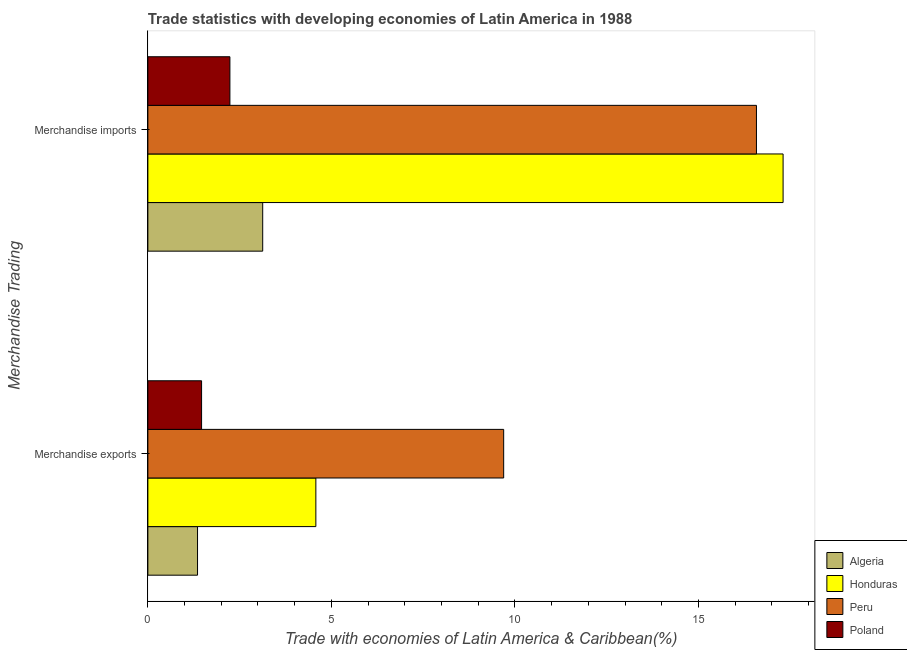How many different coloured bars are there?
Provide a short and direct response. 4. Are the number of bars per tick equal to the number of legend labels?
Ensure brevity in your answer.  Yes. How many bars are there on the 2nd tick from the bottom?
Make the answer very short. 4. What is the label of the 1st group of bars from the top?
Keep it short and to the point. Merchandise imports. What is the merchandise imports in Algeria?
Your response must be concise. 3.13. Across all countries, what is the maximum merchandise exports?
Make the answer very short. 9.69. Across all countries, what is the minimum merchandise exports?
Provide a succinct answer. 1.35. In which country was the merchandise exports minimum?
Provide a short and direct response. Algeria. What is the total merchandise exports in the graph?
Make the answer very short. 17.09. What is the difference between the merchandise exports in Poland and that in Algeria?
Your answer should be very brief. 0.11. What is the difference between the merchandise imports in Poland and the merchandise exports in Peru?
Your response must be concise. -7.46. What is the average merchandise exports per country?
Provide a succinct answer. 4.27. What is the difference between the merchandise exports and merchandise imports in Peru?
Ensure brevity in your answer.  -6.89. What is the ratio of the merchandise exports in Poland to that in Peru?
Your answer should be very brief. 0.15. What does the 2nd bar from the bottom in Merchandise exports represents?
Make the answer very short. Honduras. Are all the bars in the graph horizontal?
Offer a very short reply. Yes. How many countries are there in the graph?
Offer a very short reply. 4. What is the difference between two consecutive major ticks on the X-axis?
Provide a succinct answer. 5. Does the graph contain any zero values?
Provide a short and direct response. No. Where does the legend appear in the graph?
Provide a succinct answer. Bottom right. How many legend labels are there?
Offer a very short reply. 4. How are the legend labels stacked?
Provide a succinct answer. Vertical. What is the title of the graph?
Provide a short and direct response. Trade statistics with developing economies of Latin America in 1988. What is the label or title of the X-axis?
Make the answer very short. Trade with economies of Latin America & Caribbean(%). What is the label or title of the Y-axis?
Give a very brief answer. Merchandise Trading. What is the Trade with economies of Latin America & Caribbean(%) of Algeria in Merchandise exports?
Your response must be concise. 1.35. What is the Trade with economies of Latin America & Caribbean(%) in Honduras in Merchandise exports?
Offer a terse response. 4.58. What is the Trade with economies of Latin America & Caribbean(%) in Peru in Merchandise exports?
Your response must be concise. 9.69. What is the Trade with economies of Latin America & Caribbean(%) of Poland in Merchandise exports?
Provide a short and direct response. 1.46. What is the Trade with economies of Latin America & Caribbean(%) in Algeria in Merchandise imports?
Your answer should be very brief. 3.13. What is the Trade with economies of Latin America & Caribbean(%) of Honduras in Merchandise imports?
Give a very brief answer. 17.31. What is the Trade with economies of Latin America & Caribbean(%) of Peru in Merchandise imports?
Your answer should be very brief. 16.58. What is the Trade with economies of Latin America & Caribbean(%) of Poland in Merchandise imports?
Your answer should be very brief. 2.24. Across all Merchandise Trading, what is the maximum Trade with economies of Latin America & Caribbean(%) of Algeria?
Provide a short and direct response. 3.13. Across all Merchandise Trading, what is the maximum Trade with economies of Latin America & Caribbean(%) of Honduras?
Provide a succinct answer. 17.31. Across all Merchandise Trading, what is the maximum Trade with economies of Latin America & Caribbean(%) in Peru?
Offer a very short reply. 16.58. Across all Merchandise Trading, what is the maximum Trade with economies of Latin America & Caribbean(%) in Poland?
Give a very brief answer. 2.24. Across all Merchandise Trading, what is the minimum Trade with economies of Latin America & Caribbean(%) of Algeria?
Offer a terse response. 1.35. Across all Merchandise Trading, what is the minimum Trade with economies of Latin America & Caribbean(%) of Honduras?
Offer a terse response. 4.58. Across all Merchandise Trading, what is the minimum Trade with economies of Latin America & Caribbean(%) in Peru?
Ensure brevity in your answer.  9.69. Across all Merchandise Trading, what is the minimum Trade with economies of Latin America & Caribbean(%) of Poland?
Make the answer very short. 1.46. What is the total Trade with economies of Latin America & Caribbean(%) in Algeria in the graph?
Keep it short and to the point. 4.48. What is the total Trade with economies of Latin America & Caribbean(%) of Honduras in the graph?
Your response must be concise. 21.88. What is the total Trade with economies of Latin America & Caribbean(%) of Peru in the graph?
Keep it short and to the point. 26.27. What is the total Trade with economies of Latin America & Caribbean(%) of Poland in the graph?
Keep it short and to the point. 3.7. What is the difference between the Trade with economies of Latin America & Caribbean(%) of Algeria in Merchandise exports and that in Merchandise imports?
Make the answer very short. -1.78. What is the difference between the Trade with economies of Latin America & Caribbean(%) of Honduras in Merchandise exports and that in Merchandise imports?
Your answer should be compact. -12.73. What is the difference between the Trade with economies of Latin America & Caribbean(%) in Peru in Merchandise exports and that in Merchandise imports?
Your answer should be compact. -6.89. What is the difference between the Trade with economies of Latin America & Caribbean(%) of Poland in Merchandise exports and that in Merchandise imports?
Your response must be concise. -0.77. What is the difference between the Trade with economies of Latin America & Caribbean(%) of Algeria in Merchandise exports and the Trade with economies of Latin America & Caribbean(%) of Honduras in Merchandise imports?
Keep it short and to the point. -15.95. What is the difference between the Trade with economies of Latin America & Caribbean(%) of Algeria in Merchandise exports and the Trade with economies of Latin America & Caribbean(%) of Peru in Merchandise imports?
Your response must be concise. -15.23. What is the difference between the Trade with economies of Latin America & Caribbean(%) of Algeria in Merchandise exports and the Trade with economies of Latin America & Caribbean(%) of Poland in Merchandise imports?
Provide a short and direct response. -0.88. What is the difference between the Trade with economies of Latin America & Caribbean(%) in Honduras in Merchandise exports and the Trade with economies of Latin America & Caribbean(%) in Peru in Merchandise imports?
Offer a terse response. -12. What is the difference between the Trade with economies of Latin America & Caribbean(%) of Honduras in Merchandise exports and the Trade with economies of Latin America & Caribbean(%) of Poland in Merchandise imports?
Provide a succinct answer. 2.34. What is the difference between the Trade with economies of Latin America & Caribbean(%) in Peru in Merchandise exports and the Trade with economies of Latin America & Caribbean(%) in Poland in Merchandise imports?
Offer a very short reply. 7.46. What is the average Trade with economies of Latin America & Caribbean(%) of Algeria per Merchandise Trading?
Ensure brevity in your answer.  2.24. What is the average Trade with economies of Latin America & Caribbean(%) of Honduras per Merchandise Trading?
Provide a succinct answer. 10.94. What is the average Trade with economies of Latin America & Caribbean(%) in Peru per Merchandise Trading?
Offer a terse response. 13.14. What is the average Trade with economies of Latin America & Caribbean(%) in Poland per Merchandise Trading?
Your answer should be very brief. 1.85. What is the difference between the Trade with economies of Latin America & Caribbean(%) of Algeria and Trade with economies of Latin America & Caribbean(%) of Honduras in Merchandise exports?
Your response must be concise. -3.22. What is the difference between the Trade with economies of Latin America & Caribbean(%) in Algeria and Trade with economies of Latin America & Caribbean(%) in Peru in Merchandise exports?
Provide a short and direct response. -8.34. What is the difference between the Trade with economies of Latin America & Caribbean(%) of Algeria and Trade with economies of Latin America & Caribbean(%) of Poland in Merchandise exports?
Your response must be concise. -0.11. What is the difference between the Trade with economies of Latin America & Caribbean(%) in Honduras and Trade with economies of Latin America & Caribbean(%) in Peru in Merchandise exports?
Your answer should be very brief. -5.12. What is the difference between the Trade with economies of Latin America & Caribbean(%) of Honduras and Trade with economies of Latin America & Caribbean(%) of Poland in Merchandise exports?
Provide a short and direct response. 3.11. What is the difference between the Trade with economies of Latin America & Caribbean(%) of Peru and Trade with economies of Latin America & Caribbean(%) of Poland in Merchandise exports?
Give a very brief answer. 8.23. What is the difference between the Trade with economies of Latin America & Caribbean(%) of Algeria and Trade with economies of Latin America & Caribbean(%) of Honduras in Merchandise imports?
Your answer should be very brief. -14.18. What is the difference between the Trade with economies of Latin America & Caribbean(%) of Algeria and Trade with economies of Latin America & Caribbean(%) of Peru in Merchandise imports?
Give a very brief answer. -13.45. What is the difference between the Trade with economies of Latin America & Caribbean(%) of Algeria and Trade with economies of Latin America & Caribbean(%) of Poland in Merchandise imports?
Ensure brevity in your answer.  0.89. What is the difference between the Trade with economies of Latin America & Caribbean(%) in Honduras and Trade with economies of Latin America & Caribbean(%) in Peru in Merchandise imports?
Give a very brief answer. 0.73. What is the difference between the Trade with economies of Latin America & Caribbean(%) of Honduras and Trade with economies of Latin America & Caribbean(%) of Poland in Merchandise imports?
Your answer should be very brief. 15.07. What is the difference between the Trade with economies of Latin America & Caribbean(%) in Peru and Trade with economies of Latin America & Caribbean(%) in Poland in Merchandise imports?
Your answer should be compact. 14.35. What is the ratio of the Trade with economies of Latin America & Caribbean(%) in Algeria in Merchandise exports to that in Merchandise imports?
Provide a short and direct response. 0.43. What is the ratio of the Trade with economies of Latin America & Caribbean(%) in Honduras in Merchandise exports to that in Merchandise imports?
Keep it short and to the point. 0.26. What is the ratio of the Trade with economies of Latin America & Caribbean(%) of Peru in Merchandise exports to that in Merchandise imports?
Offer a very short reply. 0.58. What is the ratio of the Trade with economies of Latin America & Caribbean(%) in Poland in Merchandise exports to that in Merchandise imports?
Offer a very short reply. 0.65. What is the difference between the highest and the second highest Trade with economies of Latin America & Caribbean(%) in Algeria?
Your response must be concise. 1.78. What is the difference between the highest and the second highest Trade with economies of Latin America & Caribbean(%) in Honduras?
Give a very brief answer. 12.73. What is the difference between the highest and the second highest Trade with economies of Latin America & Caribbean(%) of Peru?
Your answer should be very brief. 6.89. What is the difference between the highest and the second highest Trade with economies of Latin America & Caribbean(%) in Poland?
Your answer should be compact. 0.77. What is the difference between the highest and the lowest Trade with economies of Latin America & Caribbean(%) of Algeria?
Provide a short and direct response. 1.78. What is the difference between the highest and the lowest Trade with economies of Latin America & Caribbean(%) in Honduras?
Keep it short and to the point. 12.73. What is the difference between the highest and the lowest Trade with economies of Latin America & Caribbean(%) in Peru?
Provide a short and direct response. 6.89. What is the difference between the highest and the lowest Trade with economies of Latin America & Caribbean(%) in Poland?
Offer a terse response. 0.77. 